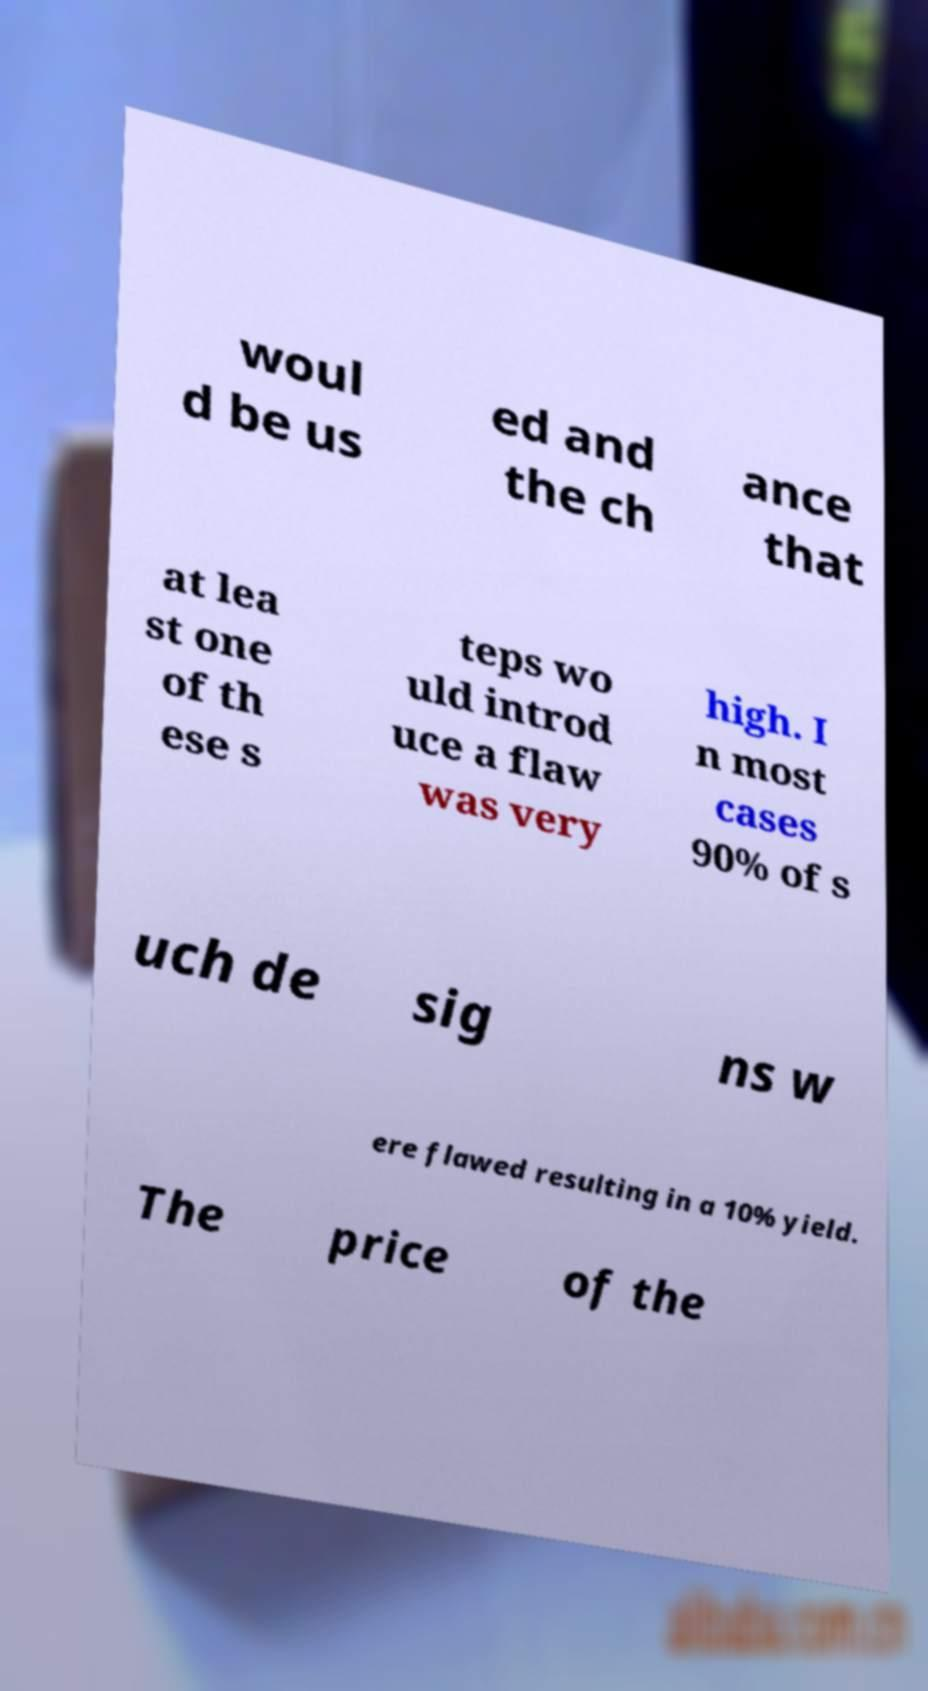Please read and relay the text visible in this image. What does it say? woul d be us ed and the ch ance that at lea st one of th ese s teps wo uld introd uce a flaw was very high. I n most cases 90% of s uch de sig ns w ere flawed resulting in a 10% yield. The price of the 